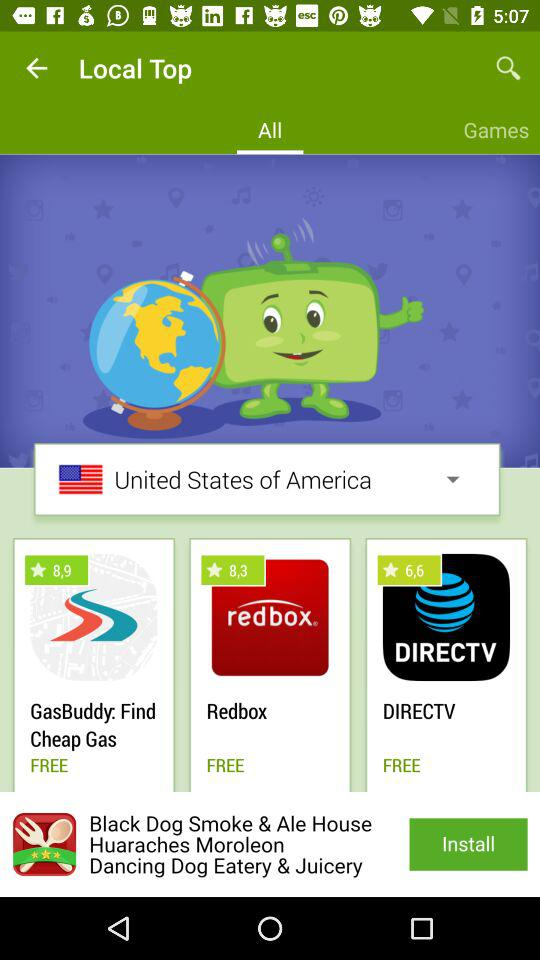What is the rating for the "Redbox"? The rating for the "Redbox" is 8.3. 